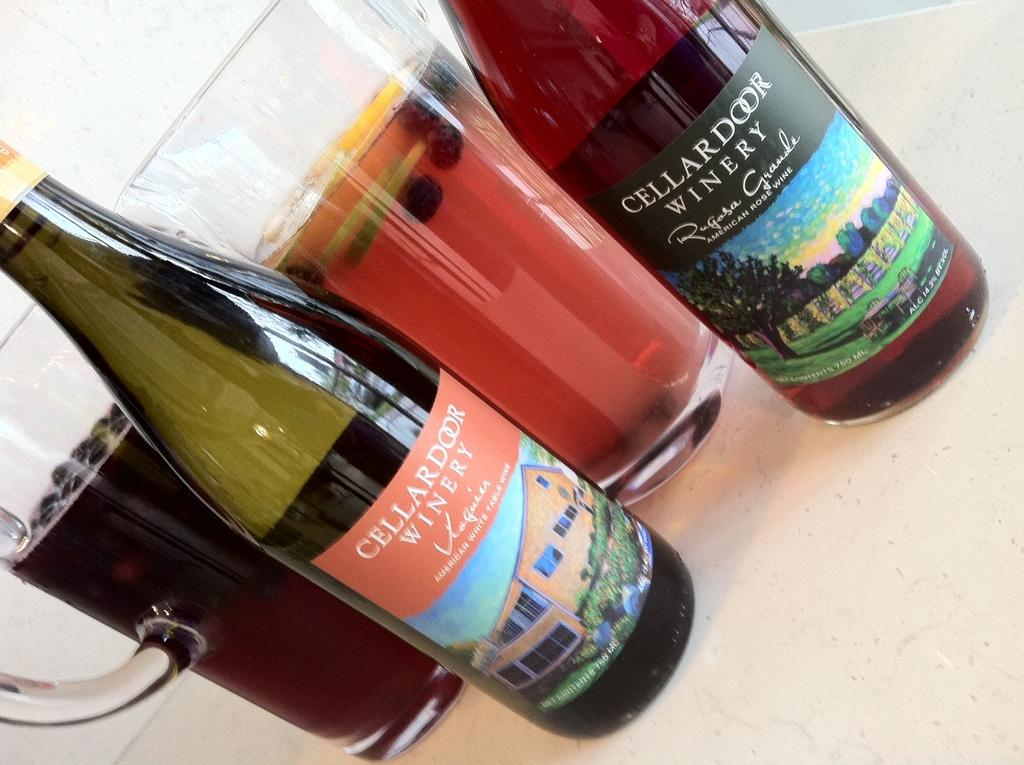<image>
Give a short and clear explanation of the subsequent image. Two bottles of Cellar Door Winery white and rose wines in front of two pitchers that are nearly full. 